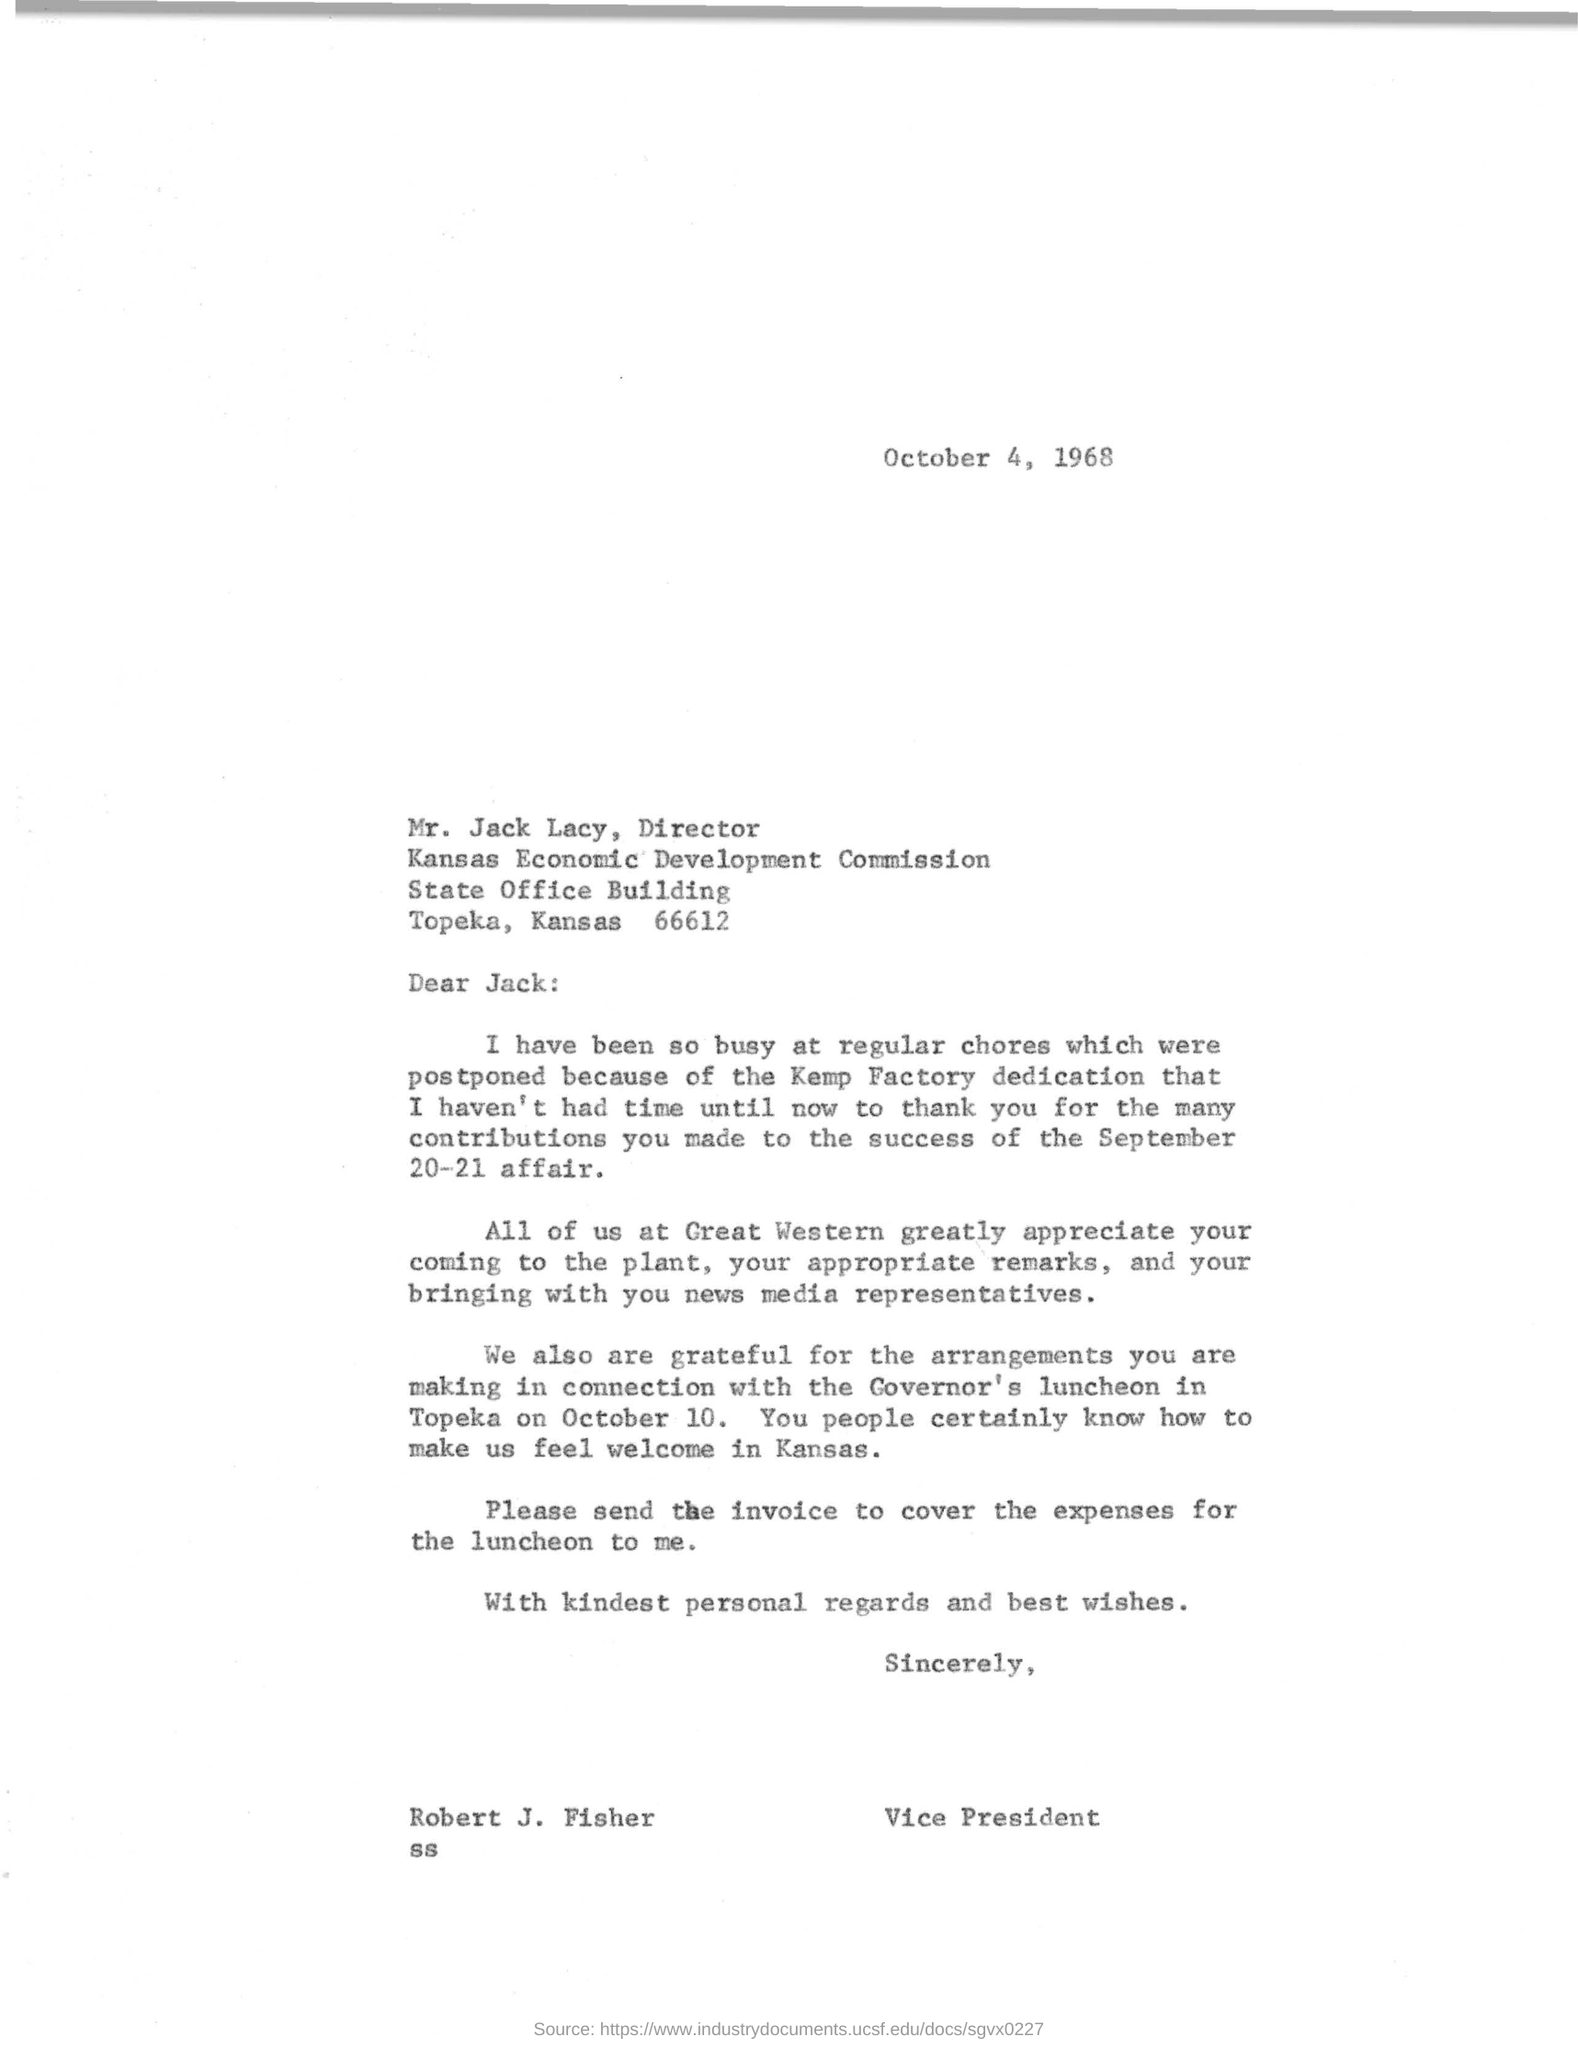Mr jack is a director at what place.
Give a very brief answer. KANSAS ECONOMIC DEVELOPMENT COMMISSION. What is the name of the vice president.
Ensure brevity in your answer.  ROBERT J. FISHER. For which event is robert j fisher thanking mr jack.
Provide a short and direct response. SEPTEMBER 20-21 AFFAIR. Robert  Fisher is working for which company?
Keep it short and to the point. Great western. For what event is mr jack making recent arrangements
Your answer should be very brief. GOVERNOR'S LUNCHEON. When is the event going to be held and where.
Your answer should be very brief. TOPEKA ON OCTOBER 10. What is the appointment of mr jack.
Keep it short and to the point. DIRECTOR. When did mr robert wrote to mr jack.
Your answer should be compact. OCTOBER 4, 1968. Whom did mr jack brought with himself at great western for which mr robert is thanking.
Provide a succinct answer. NEWS MEDIA REPRESENTATIVES. What is mr robert asking from mr jack for governors luncheon.
Your answer should be very brief. Send the invoice to cover the expenses for the luncheon to me. 